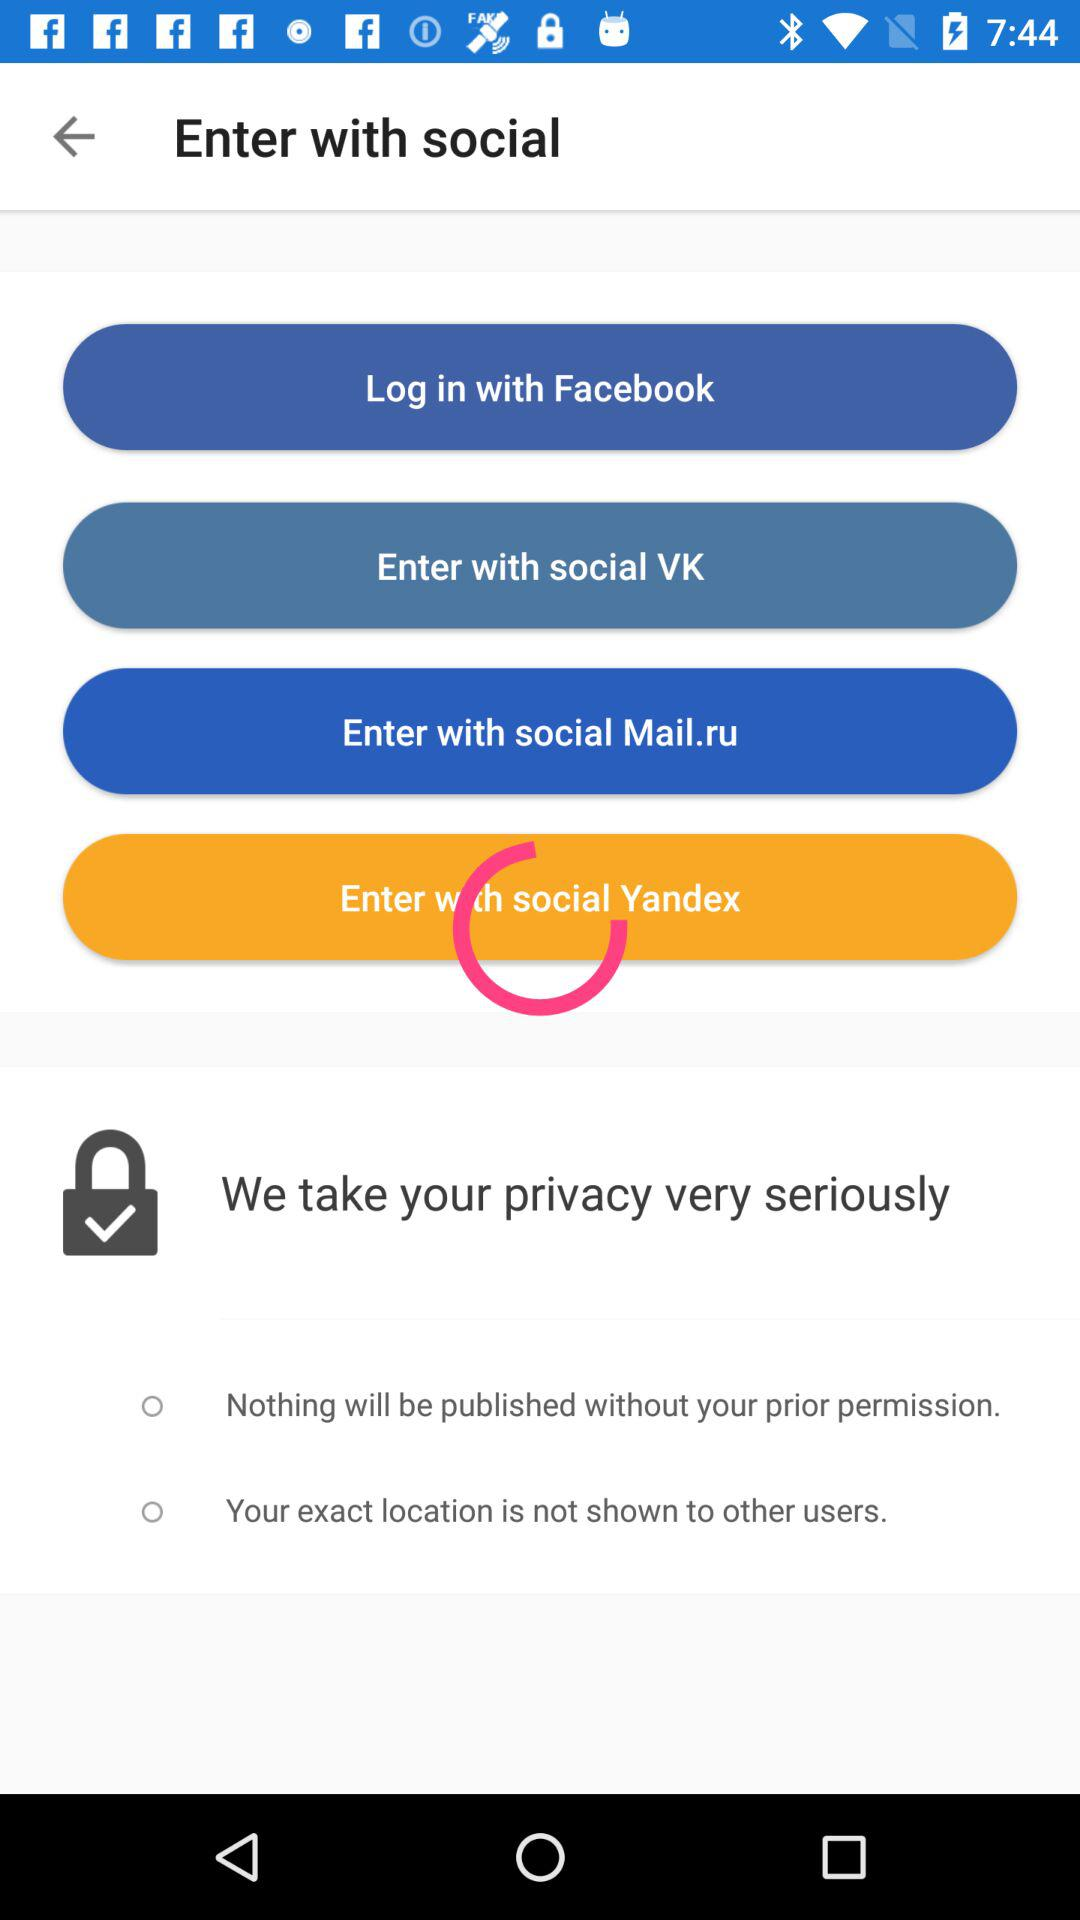Through what applications can we enter? The applications you can enter with are "social VK", "social Mail.ru" and "social Yandex". 